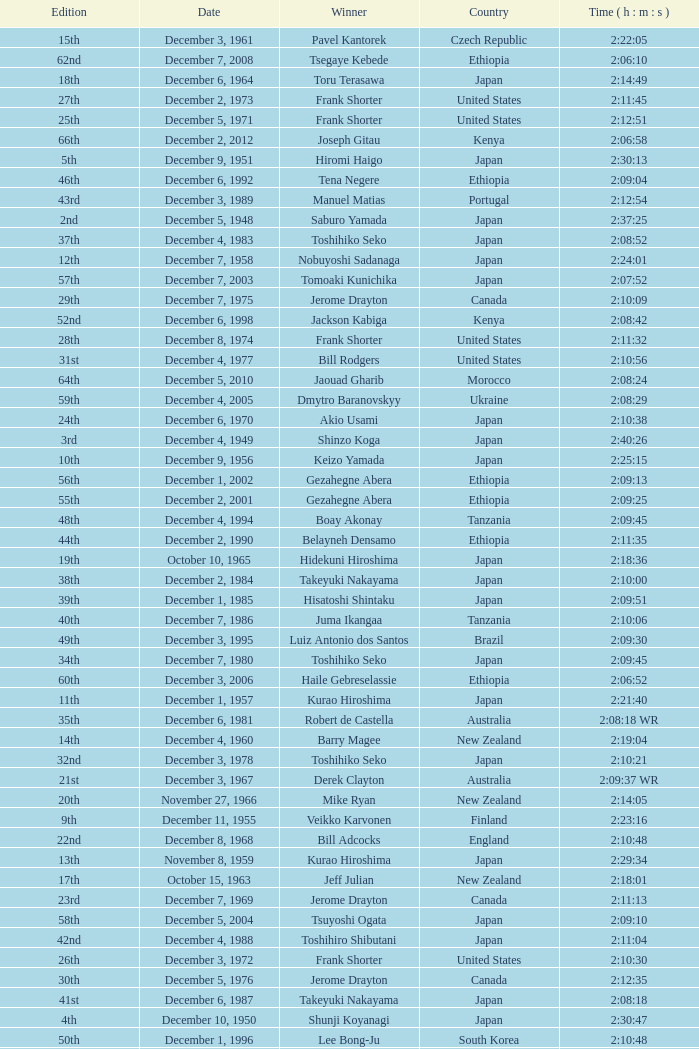What was the nationality of the winner for the 20th Edition? New Zealand. 